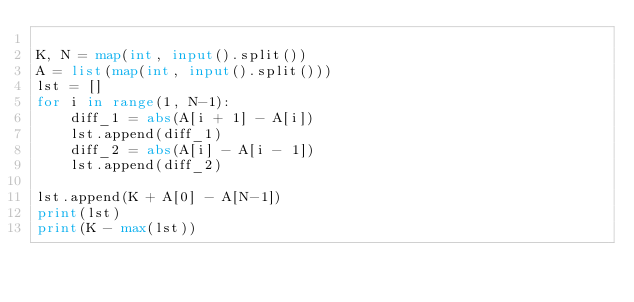Convert code to text. <code><loc_0><loc_0><loc_500><loc_500><_Python_>
K, N = map(int, input().split())
A = list(map(int, input().split()))
lst = []
for i in range(1, N-1):
    diff_1 = abs(A[i + 1] - A[i])
    lst.append(diff_1)
    diff_2 = abs(A[i] - A[i - 1])
    lst.append(diff_2)

lst.append(K + A[0] - A[N-1])
print(lst)
print(K - max(lst))</code> 